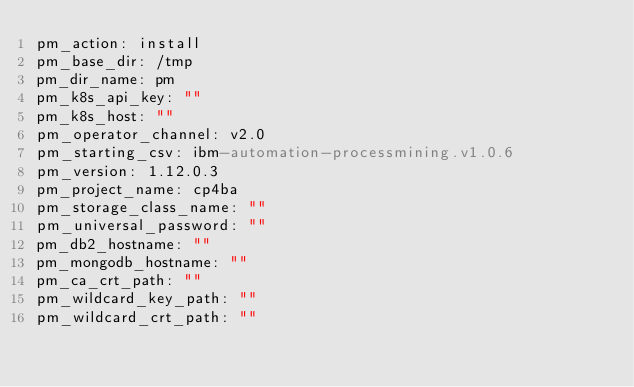Convert code to text. <code><loc_0><loc_0><loc_500><loc_500><_YAML_>pm_action: install
pm_base_dir: /tmp
pm_dir_name: pm
pm_k8s_api_key: ""
pm_k8s_host: ""
pm_operator_channel: v2.0
pm_starting_csv: ibm-automation-processmining.v1.0.6
pm_version: 1.12.0.3
pm_project_name: cp4ba
pm_storage_class_name: ""
pm_universal_password: ""
pm_db2_hostname: ""
pm_mongodb_hostname: ""
pm_ca_crt_path: ""
pm_wildcard_key_path: ""
pm_wildcard_crt_path: ""
</code> 